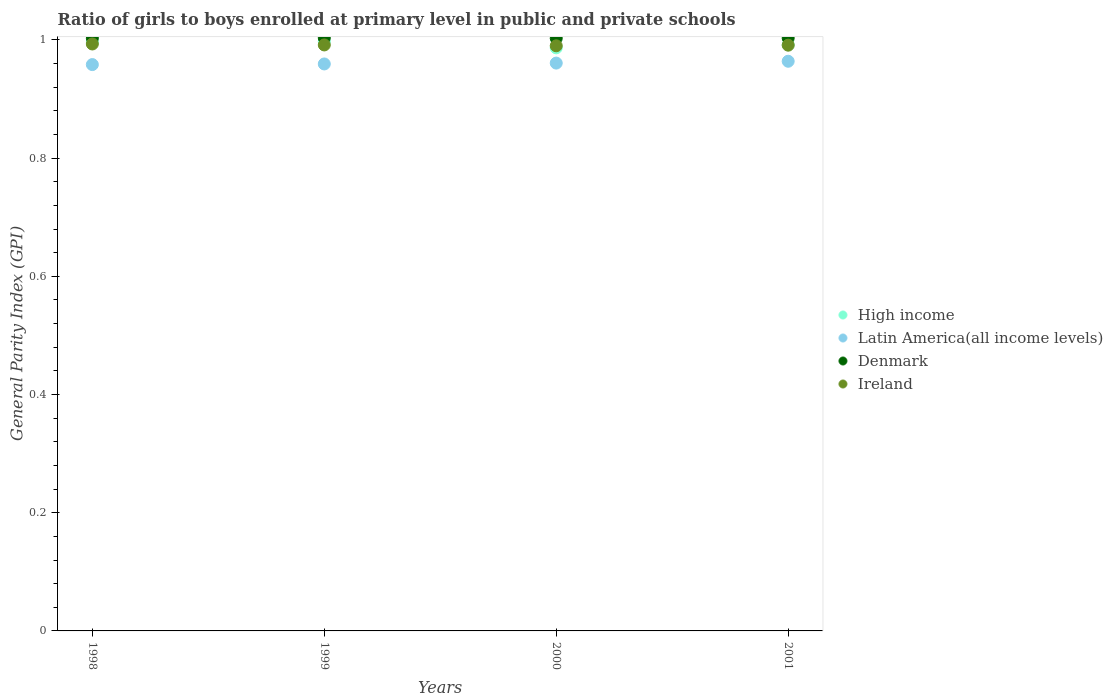How many different coloured dotlines are there?
Your answer should be compact. 4. Is the number of dotlines equal to the number of legend labels?
Provide a succinct answer. Yes. What is the general parity index in Latin America(all income levels) in 2000?
Offer a terse response. 0.96. Across all years, what is the maximum general parity index in Ireland?
Ensure brevity in your answer.  0.99. Across all years, what is the minimum general parity index in Ireland?
Keep it short and to the point. 0.99. In which year was the general parity index in Ireland maximum?
Your response must be concise. 1998. What is the total general parity index in High income in the graph?
Provide a succinct answer. 3.97. What is the difference between the general parity index in Ireland in 2000 and that in 2001?
Provide a succinct answer. -0. What is the difference between the general parity index in Latin America(all income levels) in 1998 and the general parity index in Ireland in 2000?
Offer a very short reply. -0.03. What is the average general parity index in High income per year?
Provide a short and direct response. 0.99. In the year 2001, what is the difference between the general parity index in Denmark and general parity index in Latin America(all income levels)?
Offer a terse response. 0.04. In how many years, is the general parity index in High income greater than 0.44?
Ensure brevity in your answer.  4. What is the ratio of the general parity index in Ireland in 1998 to that in 2001?
Provide a succinct answer. 1. Is the general parity index in Latin America(all income levels) in 2000 less than that in 2001?
Your response must be concise. Yes. Is the difference between the general parity index in Denmark in 1998 and 2001 greater than the difference between the general parity index in Latin America(all income levels) in 1998 and 2001?
Ensure brevity in your answer.  Yes. What is the difference between the highest and the second highest general parity index in Denmark?
Your answer should be compact. 0. What is the difference between the highest and the lowest general parity index in Denmark?
Your answer should be compact. 0. Is it the case that in every year, the sum of the general parity index in Ireland and general parity index in High income  is greater than the general parity index in Latin America(all income levels)?
Give a very brief answer. Yes. Is the general parity index in Denmark strictly less than the general parity index in High income over the years?
Your answer should be very brief. No. Does the graph contain any zero values?
Your answer should be compact. No. Does the graph contain grids?
Offer a very short reply. No. Where does the legend appear in the graph?
Provide a succinct answer. Center right. How many legend labels are there?
Ensure brevity in your answer.  4. What is the title of the graph?
Offer a terse response. Ratio of girls to boys enrolled at primary level in public and private schools. Does "Benin" appear as one of the legend labels in the graph?
Offer a very short reply. No. What is the label or title of the X-axis?
Your answer should be very brief. Years. What is the label or title of the Y-axis?
Offer a terse response. General Parity Index (GPI). What is the General Parity Index (GPI) of High income in 1998?
Your response must be concise. 1. What is the General Parity Index (GPI) in Latin America(all income levels) in 1998?
Keep it short and to the point. 0.96. What is the General Parity Index (GPI) in Denmark in 1998?
Ensure brevity in your answer.  1. What is the General Parity Index (GPI) of Ireland in 1998?
Provide a short and direct response. 0.99. What is the General Parity Index (GPI) in High income in 1999?
Offer a very short reply. 1. What is the General Parity Index (GPI) in Latin America(all income levels) in 1999?
Provide a short and direct response. 0.96. What is the General Parity Index (GPI) of Denmark in 1999?
Give a very brief answer. 1. What is the General Parity Index (GPI) in Ireland in 1999?
Provide a short and direct response. 0.99. What is the General Parity Index (GPI) in High income in 2000?
Provide a succinct answer. 0.99. What is the General Parity Index (GPI) of Latin America(all income levels) in 2000?
Your answer should be compact. 0.96. What is the General Parity Index (GPI) of Denmark in 2000?
Your response must be concise. 1. What is the General Parity Index (GPI) of Ireland in 2000?
Offer a very short reply. 0.99. What is the General Parity Index (GPI) of High income in 2001?
Your answer should be compact. 0.99. What is the General Parity Index (GPI) in Latin America(all income levels) in 2001?
Your answer should be very brief. 0.96. What is the General Parity Index (GPI) of Denmark in 2001?
Offer a very short reply. 1. What is the General Parity Index (GPI) in Ireland in 2001?
Give a very brief answer. 0.99. Across all years, what is the maximum General Parity Index (GPI) of High income?
Your response must be concise. 1. Across all years, what is the maximum General Parity Index (GPI) of Latin America(all income levels)?
Offer a terse response. 0.96. Across all years, what is the maximum General Parity Index (GPI) of Denmark?
Keep it short and to the point. 1. Across all years, what is the maximum General Parity Index (GPI) in Ireland?
Your answer should be compact. 0.99. Across all years, what is the minimum General Parity Index (GPI) in High income?
Provide a short and direct response. 0.99. Across all years, what is the minimum General Parity Index (GPI) in Latin America(all income levels)?
Make the answer very short. 0.96. Across all years, what is the minimum General Parity Index (GPI) in Denmark?
Offer a terse response. 1. Across all years, what is the minimum General Parity Index (GPI) in Ireland?
Your answer should be very brief. 0.99. What is the total General Parity Index (GPI) in High income in the graph?
Provide a succinct answer. 3.97. What is the total General Parity Index (GPI) of Latin America(all income levels) in the graph?
Provide a succinct answer. 3.84. What is the total General Parity Index (GPI) in Denmark in the graph?
Offer a very short reply. 4.01. What is the total General Parity Index (GPI) in Ireland in the graph?
Provide a succinct answer. 3.97. What is the difference between the General Parity Index (GPI) in High income in 1998 and that in 1999?
Give a very brief answer. -0. What is the difference between the General Parity Index (GPI) in Latin America(all income levels) in 1998 and that in 1999?
Offer a terse response. -0. What is the difference between the General Parity Index (GPI) of Denmark in 1998 and that in 1999?
Your answer should be compact. -0. What is the difference between the General Parity Index (GPI) in Ireland in 1998 and that in 1999?
Provide a succinct answer. 0. What is the difference between the General Parity Index (GPI) of High income in 1998 and that in 2000?
Provide a short and direct response. 0.01. What is the difference between the General Parity Index (GPI) in Latin America(all income levels) in 1998 and that in 2000?
Provide a succinct answer. -0. What is the difference between the General Parity Index (GPI) of Ireland in 1998 and that in 2000?
Keep it short and to the point. 0. What is the difference between the General Parity Index (GPI) in High income in 1998 and that in 2001?
Your answer should be very brief. 0. What is the difference between the General Parity Index (GPI) in Latin America(all income levels) in 1998 and that in 2001?
Your response must be concise. -0.01. What is the difference between the General Parity Index (GPI) of Denmark in 1998 and that in 2001?
Ensure brevity in your answer.  -0. What is the difference between the General Parity Index (GPI) in Ireland in 1998 and that in 2001?
Your response must be concise. 0. What is the difference between the General Parity Index (GPI) of High income in 1999 and that in 2000?
Provide a short and direct response. 0.01. What is the difference between the General Parity Index (GPI) of Latin America(all income levels) in 1999 and that in 2000?
Your answer should be very brief. -0. What is the difference between the General Parity Index (GPI) of Denmark in 1999 and that in 2000?
Offer a very short reply. 0. What is the difference between the General Parity Index (GPI) of Ireland in 1999 and that in 2000?
Provide a succinct answer. 0. What is the difference between the General Parity Index (GPI) in High income in 1999 and that in 2001?
Offer a very short reply. 0.01. What is the difference between the General Parity Index (GPI) of Latin America(all income levels) in 1999 and that in 2001?
Ensure brevity in your answer.  -0. What is the difference between the General Parity Index (GPI) of High income in 2000 and that in 2001?
Your answer should be compact. -0.01. What is the difference between the General Parity Index (GPI) of Latin America(all income levels) in 2000 and that in 2001?
Provide a short and direct response. -0. What is the difference between the General Parity Index (GPI) of Denmark in 2000 and that in 2001?
Provide a short and direct response. -0. What is the difference between the General Parity Index (GPI) of Ireland in 2000 and that in 2001?
Provide a short and direct response. -0. What is the difference between the General Parity Index (GPI) of High income in 1998 and the General Parity Index (GPI) of Latin America(all income levels) in 1999?
Offer a very short reply. 0.04. What is the difference between the General Parity Index (GPI) of High income in 1998 and the General Parity Index (GPI) of Denmark in 1999?
Give a very brief answer. -0.01. What is the difference between the General Parity Index (GPI) of High income in 1998 and the General Parity Index (GPI) of Ireland in 1999?
Ensure brevity in your answer.  0. What is the difference between the General Parity Index (GPI) in Latin America(all income levels) in 1998 and the General Parity Index (GPI) in Denmark in 1999?
Keep it short and to the point. -0.05. What is the difference between the General Parity Index (GPI) in Latin America(all income levels) in 1998 and the General Parity Index (GPI) in Ireland in 1999?
Offer a terse response. -0.03. What is the difference between the General Parity Index (GPI) in Denmark in 1998 and the General Parity Index (GPI) in Ireland in 1999?
Your answer should be very brief. 0.01. What is the difference between the General Parity Index (GPI) in High income in 1998 and the General Parity Index (GPI) in Latin America(all income levels) in 2000?
Offer a very short reply. 0.04. What is the difference between the General Parity Index (GPI) of High income in 1998 and the General Parity Index (GPI) of Denmark in 2000?
Your answer should be very brief. -0.01. What is the difference between the General Parity Index (GPI) of High income in 1998 and the General Parity Index (GPI) of Ireland in 2000?
Offer a very short reply. 0.01. What is the difference between the General Parity Index (GPI) in Latin America(all income levels) in 1998 and the General Parity Index (GPI) in Denmark in 2000?
Offer a terse response. -0.04. What is the difference between the General Parity Index (GPI) of Latin America(all income levels) in 1998 and the General Parity Index (GPI) of Ireland in 2000?
Your answer should be very brief. -0.03. What is the difference between the General Parity Index (GPI) of Denmark in 1998 and the General Parity Index (GPI) of Ireland in 2000?
Provide a short and direct response. 0.01. What is the difference between the General Parity Index (GPI) in High income in 1998 and the General Parity Index (GPI) in Latin America(all income levels) in 2001?
Keep it short and to the point. 0.03. What is the difference between the General Parity Index (GPI) in High income in 1998 and the General Parity Index (GPI) in Denmark in 2001?
Your answer should be compact. -0.01. What is the difference between the General Parity Index (GPI) in High income in 1998 and the General Parity Index (GPI) in Ireland in 2001?
Your answer should be very brief. 0.01. What is the difference between the General Parity Index (GPI) of Latin America(all income levels) in 1998 and the General Parity Index (GPI) of Denmark in 2001?
Provide a succinct answer. -0.04. What is the difference between the General Parity Index (GPI) in Latin America(all income levels) in 1998 and the General Parity Index (GPI) in Ireland in 2001?
Your answer should be very brief. -0.03. What is the difference between the General Parity Index (GPI) of Denmark in 1998 and the General Parity Index (GPI) of Ireland in 2001?
Your response must be concise. 0.01. What is the difference between the General Parity Index (GPI) in High income in 1999 and the General Parity Index (GPI) in Latin America(all income levels) in 2000?
Your response must be concise. 0.04. What is the difference between the General Parity Index (GPI) of High income in 1999 and the General Parity Index (GPI) of Denmark in 2000?
Provide a succinct answer. -0.01. What is the difference between the General Parity Index (GPI) in High income in 1999 and the General Parity Index (GPI) in Ireland in 2000?
Offer a very short reply. 0.01. What is the difference between the General Parity Index (GPI) of Latin America(all income levels) in 1999 and the General Parity Index (GPI) of Denmark in 2000?
Your answer should be very brief. -0.04. What is the difference between the General Parity Index (GPI) in Latin America(all income levels) in 1999 and the General Parity Index (GPI) in Ireland in 2000?
Your answer should be compact. -0.03. What is the difference between the General Parity Index (GPI) of Denmark in 1999 and the General Parity Index (GPI) of Ireland in 2000?
Offer a terse response. 0.01. What is the difference between the General Parity Index (GPI) of High income in 1999 and the General Parity Index (GPI) of Denmark in 2001?
Your answer should be compact. -0.01. What is the difference between the General Parity Index (GPI) in High income in 1999 and the General Parity Index (GPI) in Ireland in 2001?
Your answer should be very brief. 0.01. What is the difference between the General Parity Index (GPI) in Latin America(all income levels) in 1999 and the General Parity Index (GPI) in Denmark in 2001?
Offer a very short reply. -0.04. What is the difference between the General Parity Index (GPI) of Latin America(all income levels) in 1999 and the General Parity Index (GPI) of Ireland in 2001?
Keep it short and to the point. -0.03. What is the difference between the General Parity Index (GPI) of Denmark in 1999 and the General Parity Index (GPI) of Ireland in 2001?
Make the answer very short. 0.01. What is the difference between the General Parity Index (GPI) in High income in 2000 and the General Parity Index (GPI) in Latin America(all income levels) in 2001?
Your answer should be very brief. 0.02. What is the difference between the General Parity Index (GPI) of High income in 2000 and the General Parity Index (GPI) of Denmark in 2001?
Make the answer very short. -0.02. What is the difference between the General Parity Index (GPI) of High income in 2000 and the General Parity Index (GPI) of Ireland in 2001?
Your response must be concise. -0. What is the difference between the General Parity Index (GPI) of Latin America(all income levels) in 2000 and the General Parity Index (GPI) of Denmark in 2001?
Ensure brevity in your answer.  -0.04. What is the difference between the General Parity Index (GPI) in Latin America(all income levels) in 2000 and the General Parity Index (GPI) in Ireland in 2001?
Ensure brevity in your answer.  -0.03. What is the difference between the General Parity Index (GPI) of Denmark in 2000 and the General Parity Index (GPI) of Ireland in 2001?
Offer a very short reply. 0.01. What is the average General Parity Index (GPI) in High income per year?
Offer a terse response. 0.99. What is the average General Parity Index (GPI) of Latin America(all income levels) per year?
Offer a terse response. 0.96. What is the average General Parity Index (GPI) in Ireland per year?
Ensure brevity in your answer.  0.99. In the year 1998, what is the difference between the General Parity Index (GPI) of High income and General Parity Index (GPI) of Latin America(all income levels)?
Keep it short and to the point. 0.04. In the year 1998, what is the difference between the General Parity Index (GPI) in High income and General Parity Index (GPI) in Denmark?
Your response must be concise. -0.01. In the year 1998, what is the difference between the General Parity Index (GPI) of High income and General Parity Index (GPI) of Ireland?
Keep it short and to the point. 0. In the year 1998, what is the difference between the General Parity Index (GPI) in Latin America(all income levels) and General Parity Index (GPI) in Denmark?
Offer a very short reply. -0.04. In the year 1998, what is the difference between the General Parity Index (GPI) of Latin America(all income levels) and General Parity Index (GPI) of Ireland?
Your response must be concise. -0.03. In the year 1998, what is the difference between the General Parity Index (GPI) of Denmark and General Parity Index (GPI) of Ireland?
Your answer should be very brief. 0.01. In the year 1999, what is the difference between the General Parity Index (GPI) of High income and General Parity Index (GPI) of Latin America(all income levels)?
Give a very brief answer. 0.04. In the year 1999, what is the difference between the General Parity Index (GPI) of High income and General Parity Index (GPI) of Denmark?
Your answer should be compact. -0.01. In the year 1999, what is the difference between the General Parity Index (GPI) of High income and General Parity Index (GPI) of Ireland?
Give a very brief answer. 0.01. In the year 1999, what is the difference between the General Parity Index (GPI) of Latin America(all income levels) and General Parity Index (GPI) of Denmark?
Offer a terse response. -0.04. In the year 1999, what is the difference between the General Parity Index (GPI) of Latin America(all income levels) and General Parity Index (GPI) of Ireland?
Your answer should be very brief. -0.03. In the year 1999, what is the difference between the General Parity Index (GPI) of Denmark and General Parity Index (GPI) of Ireland?
Provide a short and direct response. 0.01. In the year 2000, what is the difference between the General Parity Index (GPI) of High income and General Parity Index (GPI) of Latin America(all income levels)?
Provide a short and direct response. 0.03. In the year 2000, what is the difference between the General Parity Index (GPI) in High income and General Parity Index (GPI) in Denmark?
Offer a terse response. -0.02. In the year 2000, what is the difference between the General Parity Index (GPI) of High income and General Parity Index (GPI) of Ireland?
Offer a terse response. -0. In the year 2000, what is the difference between the General Parity Index (GPI) in Latin America(all income levels) and General Parity Index (GPI) in Denmark?
Provide a short and direct response. -0.04. In the year 2000, what is the difference between the General Parity Index (GPI) in Latin America(all income levels) and General Parity Index (GPI) in Ireland?
Ensure brevity in your answer.  -0.03. In the year 2000, what is the difference between the General Parity Index (GPI) of Denmark and General Parity Index (GPI) of Ireland?
Provide a short and direct response. 0.01. In the year 2001, what is the difference between the General Parity Index (GPI) of High income and General Parity Index (GPI) of Latin America(all income levels)?
Provide a short and direct response. 0.03. In the year 2001, what is the difference between the General Parity Index (GPI) in High income and General Parity Index (GPI) in Denmark?
Make the answer very short. -0.01. In the year 2001, what is the difference between the General Parity Index (GPI) of High income and General Parity Index (GPI) of Ireland?
Make the answer very short. 0. In the year 2001, what is the difference between the General Parity Index (GPI) in Latin America(all income levels) and General Parity Index (GPI) in Denmark?
Your response must be concise. -0.04. In the year 2001, what is the difference between the General Parity Index (GPI) in Latin America(all income levels) and General Parity Index (GPI) in Ireland?
Ensure brevity in your answer.  -0.03. In the year 2001, what is the difference between the General Parity Index (GPI) of Denmark and General Parity Index (GPI) of Ireland?
Make the answer very short. 0.01. What is the ratio of the General Parity Index (GPI) of High income in 1998 to that in 2000?
Your answer should be very brief. 1.01. What is the ratio of the General Parity Index (GPI) in Denmark in 1998 to that in 2000?
Give a very brief answer. 1. What is the ratio of the General Parity Index (GPI) in Ireland in 1998 to that in 2000?
Offer a terse response. 1. What is the ratio of the General Parity Index (GPI) of High income in 1998 to that in 2001?
Give a very brief answer. 1. What is the ratio of the General Parity Index (GPI) in Latin America(all income levels) in 1998 to that in 2001?
Ensure brevity in your answer.  0.99. What is the ratio of the General Parity Index (GPI) in Ireland in 1998 to that in 2001?
Your answer should be compact. 1. What is the ratio of the General Parity Index (GPI) of High income in 1999 to that in 2000?
Offer a very short reply. 1.01. What is the ratio of the General Parity Index (GPI) of Ireland in 1999 to that in 2000?
Keep it short and to the point. 1. What is the ratio of the General Parity Index (GPI) of Latin America(all income levels) in 1999 to that in 2001?
Offer a terse response. 1. What is the ratio of the General Parity Index (GPI) of Denmark in 1999 to that in 2001?
Provide a short and direct response. 1. What is the ratio of the General Parity Index (GPI) of Ireland in 1999 to that in 2001?
Provide a succinct answer. 1. What is the ratio of the General Parity Index (GPI) in High income in 2000 to that in 2001?
Provide a short and direct response. 0.99. What is the ratio of the General Parity Index (GPI) of Latin America(all income levels) in 2000 to that in 2001?
Keep it short and to the point. 1. What is the ratio of the General Parity Index (GPI) in Denmark in 2000 to that in 2001?
Provide a short and direct response. 1. What is the ratio of the General Parity Index (GPI) of Ireland in 2000 to that in 2001?
Your response must be concise. 1. What is the difference between the highest and the second highest General Parity Index (GPI) of High income?
Your answer should be compact. 0. What is the difference between the highest and the second highest General Parity Index (GPI) of Latin America(all income levels)?
Your response must be concise. 0. What is the difference between the highest and the second highest General Parity Index (GPI) in Ireland?
Provide a short and direct response. 0. What is the difference between the highest and the lowest General Parity Index (GPI) of High income?
Ensure brevity in your answer.  0.01. What is the difference between the highest and the lowest General Parity Index (GPI) in Latin America(all income levels)?
Make the answer very short. 0.01. What is the difference between the highest and the lowest General Parity Index (GPI) of Denmark?
Offer a very short reply. 0. What is the difference between the highest and the lowest General Parity Index (GPI) of Ireland?
Ensure brevity in your answer.  0. 